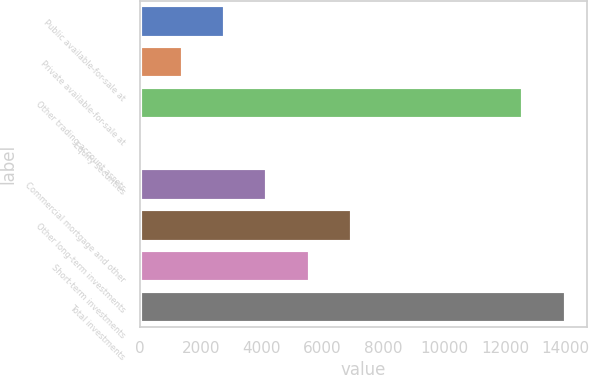Convert chart. <chart><loc_0><loc_0><loc_500><loc_500><bar_chart><fcel>Public available-for-sale at<fcel>Private available-for-sale at<fcel>Other trading account assets<fcel>Equity securities<fcel>Commercial mortgage and other<fcel>Other long-term investments<fcel>Short-term investments<fcel>Total investments<nl><fcel>2800.6<fcel>1405.8<fcel>12609<fcel>11<fcel>4195.4<fcel>6985<fcel>5590.2<fcel>14003.8<nl></chart> 